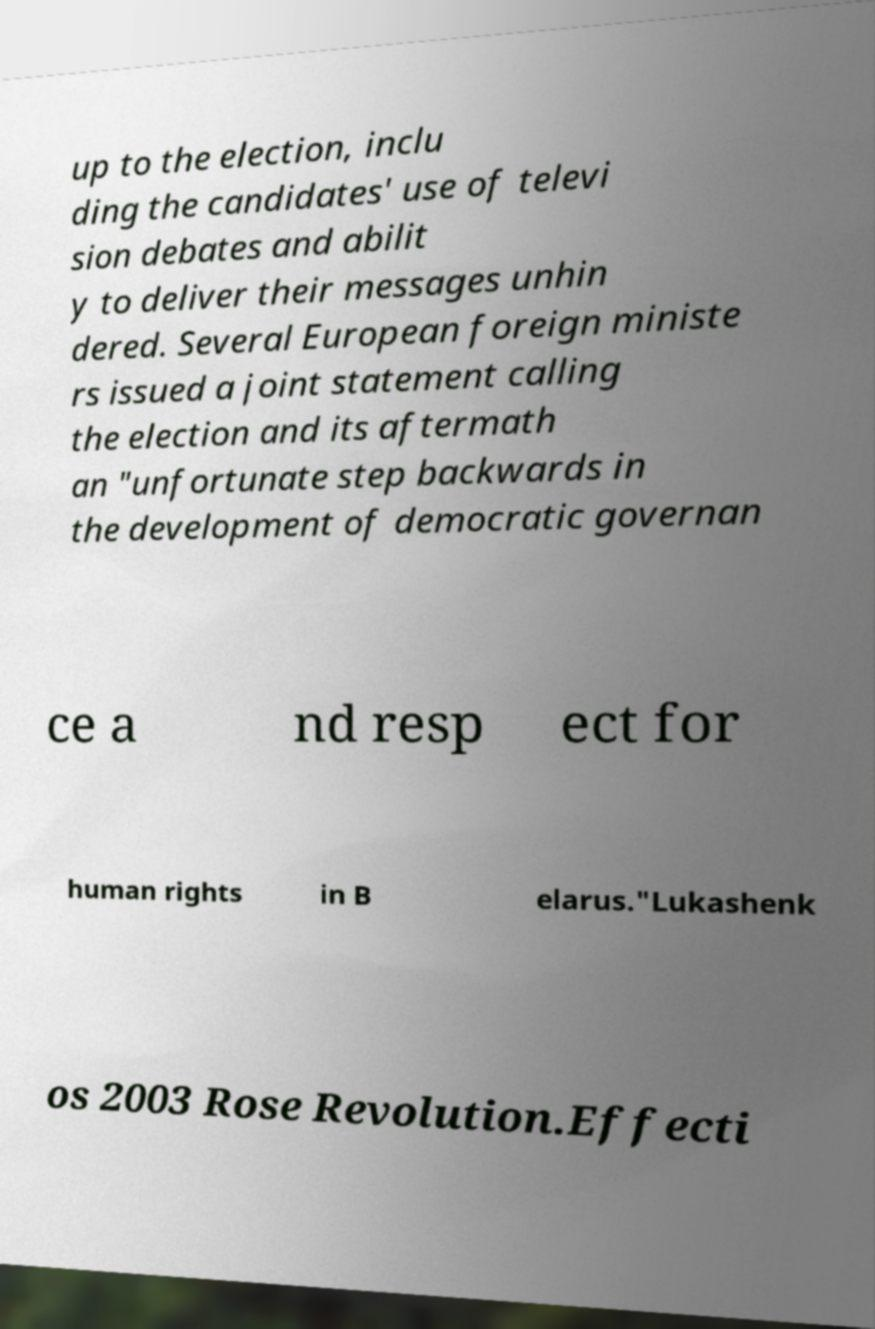For documentation purposes, I need the text within this image transcribed. Could you provide that? up to the election, inclu ding the candidates' use of televi sion debates and abilit y to deliver their messages unhin dered. Several European foreign ministe rs issued a joint statement calling the election and its aftermath an "unfortunate step backwards in the development of democratic governan ce a nd resp ect for human rights in B elarus."Lukashenk os 2003 Rose Revolution.Effecti 